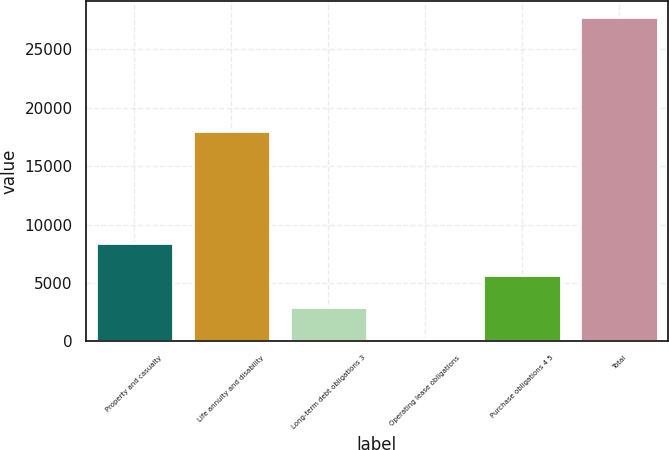<chart> <loc_0><loc_0><loc_500><loc_500><bar_chart><fcel>Property and casualty<fcel>Life annuity and disability<fcel>Long-term debt obligations 3<fcel>Operating lease obligations<fcel>Purchase obligations 4 5<fcel>Total<nl><fcel>8441.2<fcel>18037<fcel>2930.4<fcel>175<fcel>5685.8<fcel>27729<nl></chart> 